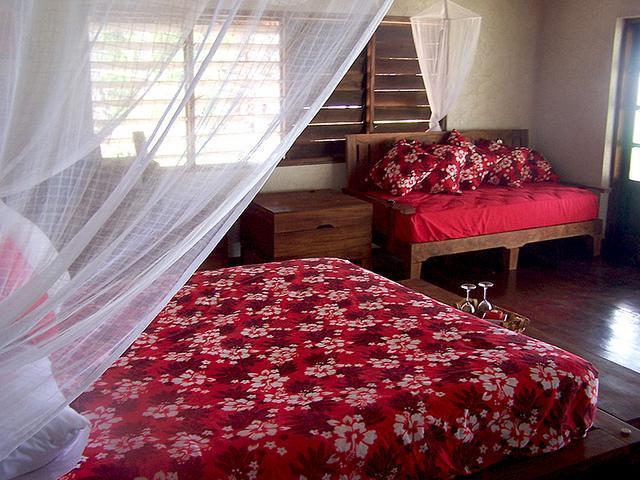What holiday is the color pattern on the bed most appropriate for?
Indicate the correct choice and explain in the format: 'Answer: answer
Rationale: rationale.'
Options: Halloween, valentines day, thanksgiving, arbor day. Answer: valentines day.
Rationale: This is a bedroom with red cover and pillows with flowers all over it. 